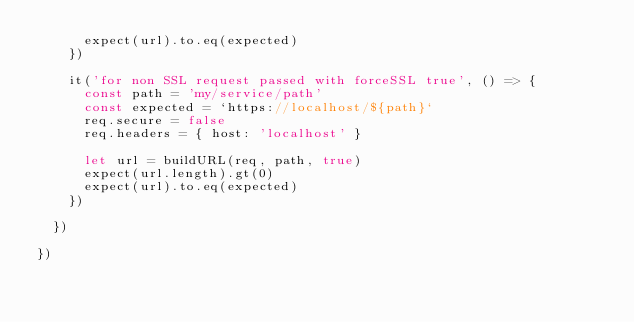Convert code to text. <code><loc_0><loc_0><loc_500><loc_500><_TypeScript_>      expect(url).to.eq(expected)
    })

    it('for non SSL request passed with forceSSL true', () => {
      const path = 'my/service/path'
      const expected = `https://localhost/${path}`
      req.secure = false
      req.headers = { host: 'localhost' }

      let url = buildURL(req, path, true)
      expect(url.length).gt(0)
      expect(url).to.eq(expected)
    })

  })

})
</code> 